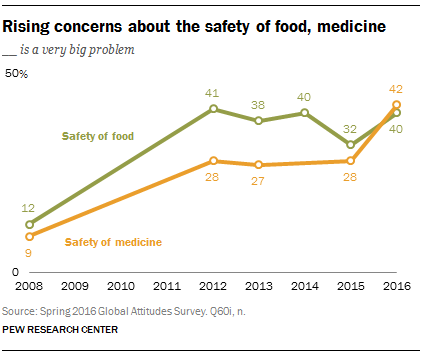Give some essential details in this illustration. In the year 2016, the value of safety in food was different from the value of safety in medicine. The value of food safety in the year 2015 was estimated to be 32. 